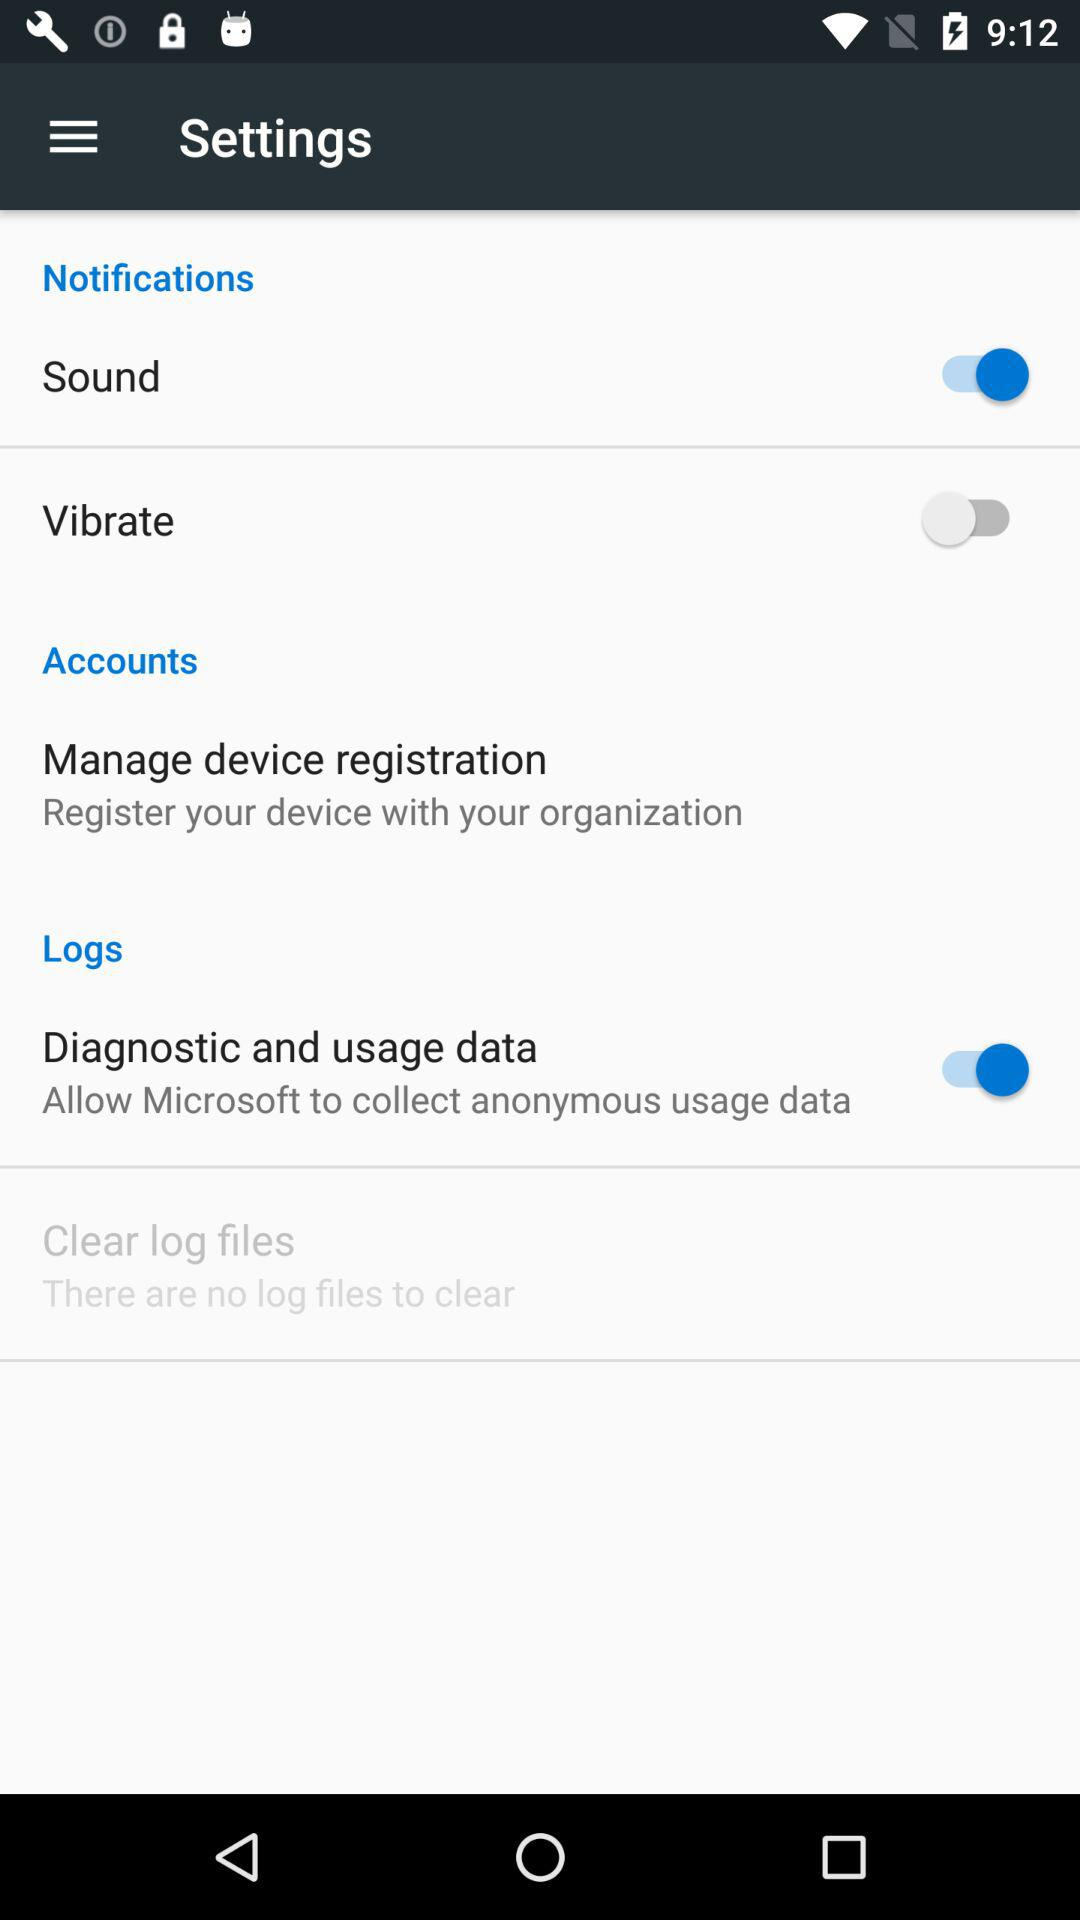What is the setting for "Sound"? The setting is "on". 